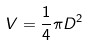<formula> <loc_0><loc_0><loc_500><loc_500>V = \frac { 1 } { 4 } \pi D ^ { 2 }</formula> 